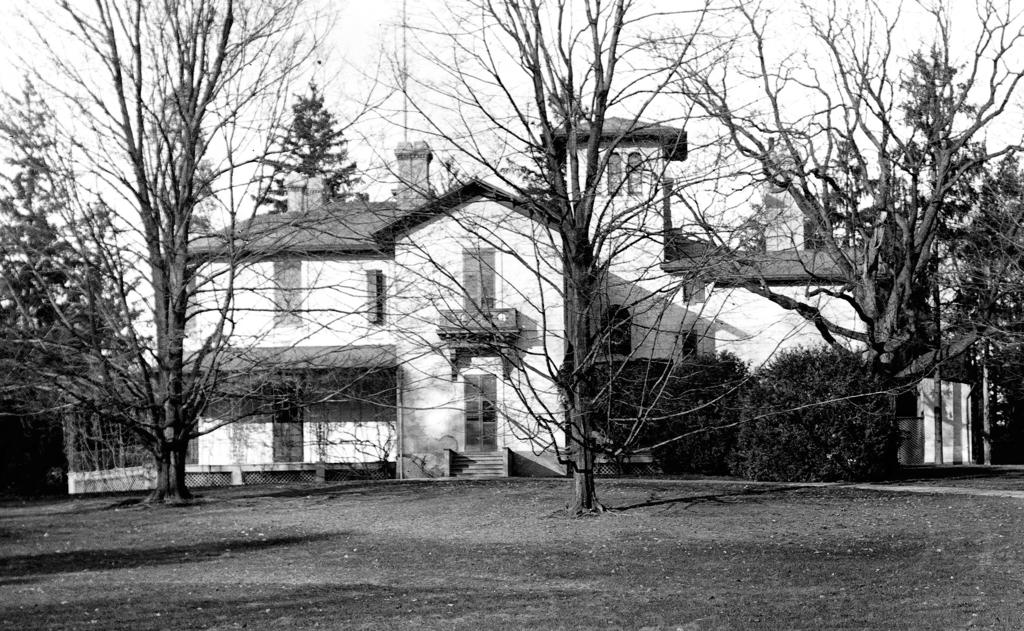What type of surface is visible in the image? There is a ground in the image. What type of structure can be seen in the image? There is a building in the image. What type of vegetation is present in the image? There are trees in the image. What is visible in the background of the image? The sky is visible in the background of the image. How many chickens are visible in the image? There are no chickens present in the image. What type of space is depicted in the image? The image does not depict any space; it features a ground, building, trees, and sky. 